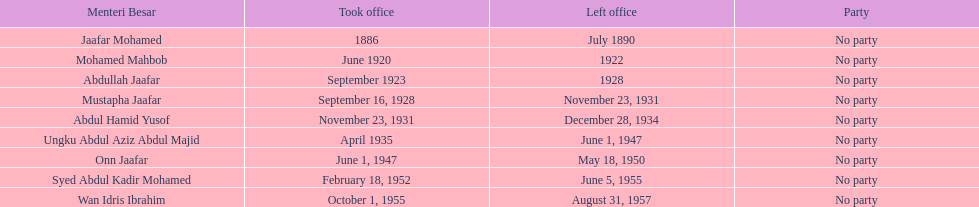Who served in the office immediately preceding abdullah jaafar? Mohamed Mahbob. 